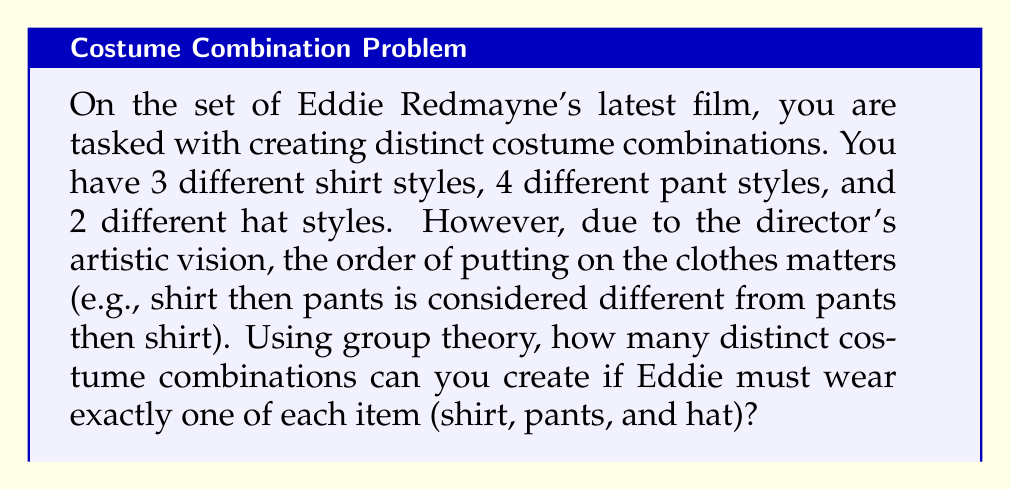What is the answer to this math problem? Let's approach this problem using group theory concepts:

1) First, we need to recognize that this problem involves permutations with repetition. The order matters, and we're selecting one item from each category.

2) In group theory, this scenario can be modeled as the direct product of symmetric groups:

   $S_3 \times S_4 \times S_2$

   Where $S_n$ represents the symmetric group on n elements.

3) The order of this group (which will give us the number of distinct combinations) is the product of the orders of each symmetric group:

   $|S_3 \times S_4 \times S_2| = |S_3| \cdot |S_4| \cdot |S_2|$

4) The order of a symmetric group $S_n$ is $n!$. Therefore:

   $|S_3| = 3!$
   $|S_4| = 4!$
   $|S_2| = 2!$

5) Substituting these values:

   $|S_3 \times S_4 \times S_2| = 3! \cdot 4! \cdot 2!$

6) Calculating:
   
   $= 6 \cdot 24 \cdot 2$
   $= 288$

Thus, there are 288 distinct costume combinations possible.
Answer: 288 distinct costume combinations 